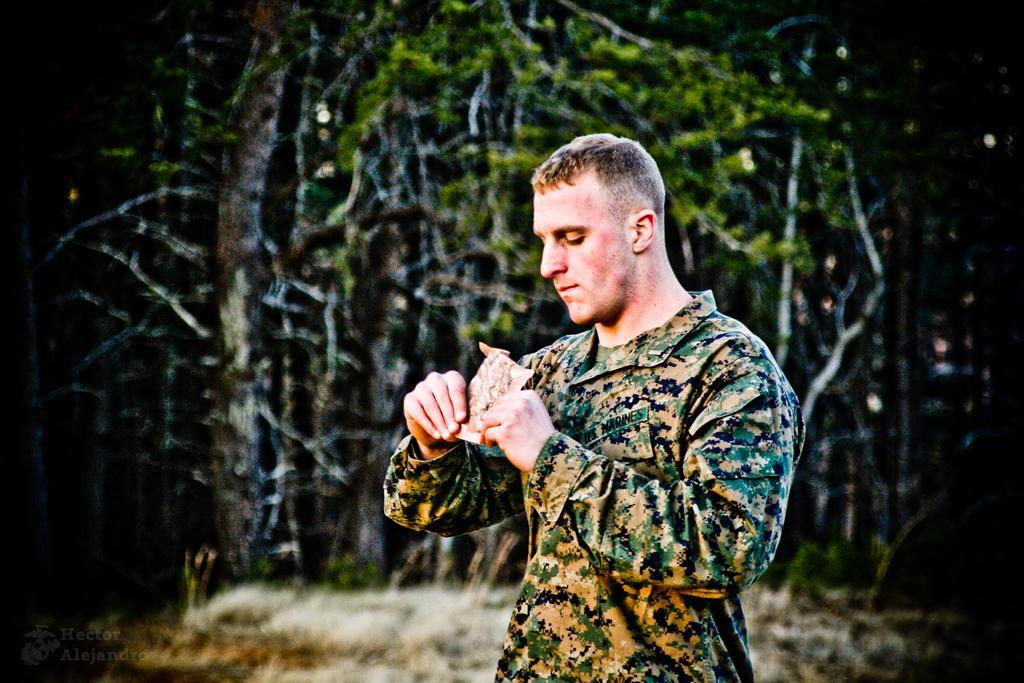Describe this image in one or two sentences. In the image,there is a man holding some object with his both hands and there are many trees behind the man. 